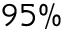Convert formula to latex. <formula><loc_0><loc_0><loc_500><loc_500>9 5 \%</formula> 